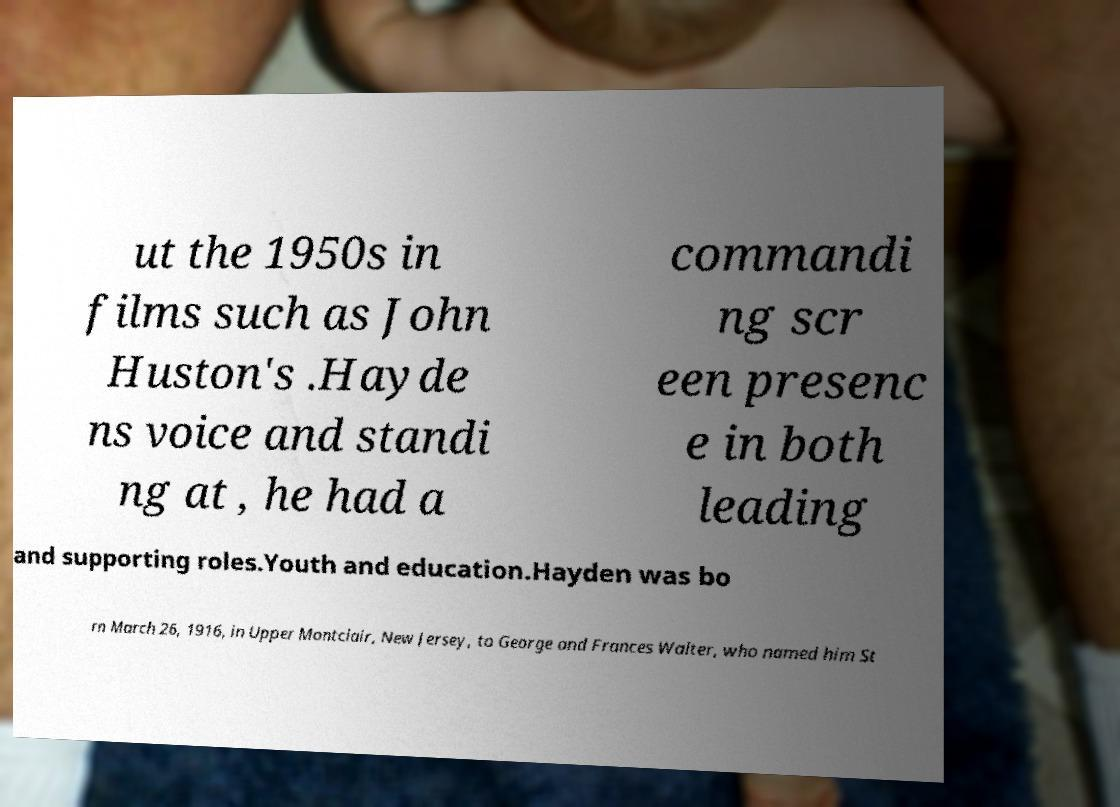Can you read and provide the text displayed in the image?This photo seems to have some interesting text. Can you extract and type it out for me? ut the 1950s in films such as John Huston's .Hayde ns voice and standi ng at , he had a commandi ng scr een presenc e in both leading and supporting roles.Youth and education.Hayden was bo rn March 26, 1916, in Upper Montclair, New Jersey, to George and Frances Walter, who named him St 